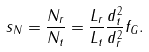<formula> <loc_0><loc_0><loc_500><loc_500>s _ { N } = \frac { N _ { r } } { N _ { t } } = \frac { L _ { r } } { L _ { t } } \frac { d ^ { 2 } _ { t } } { d ^ { 2 } _ { r } } f _ { G } .</formula> 